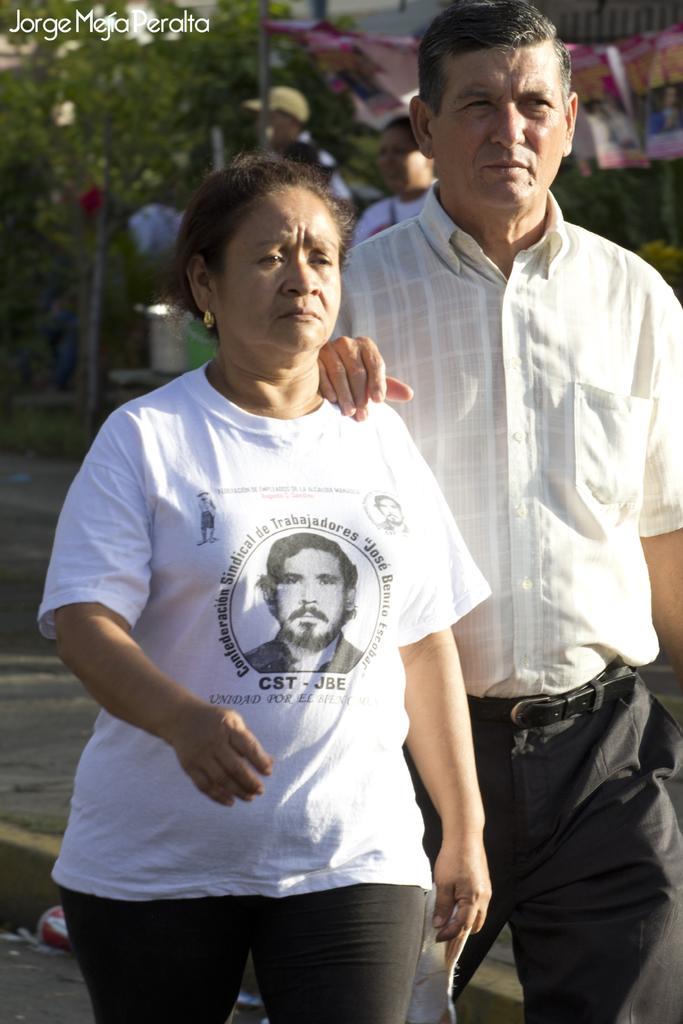Could you give a brief overview of what you see in this image? In the foreground of this picture, there is a couple walking on the road. In the background, we can see, tent, person, pole and the trees. 